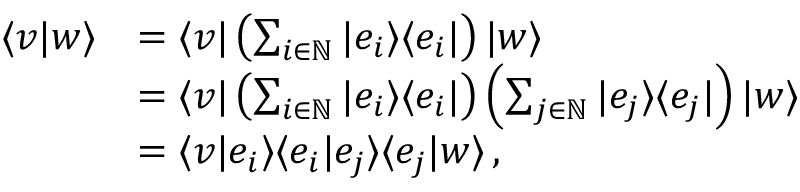Convert formula to latex. <formula><loc_0><loc_0><loc_500><loc_500>{ \begin{array} { r l } { \langle v | w \rangle } & { = \langle v | \left ( \sum _ { i \in \mathbb { N } } | e _ { i } \rangle \langle e _ { i } | \right ) | w \rangle } \\ & { = \langle v | \left ( \sum _ { i \in \mathbb { N } } | e _ { i } \rangle \langle e _ { i } | \right ) \left ( \sum _ { j \in \mathbb { N } } | e _ { j } \rangle \langle e _ { j } | \right ) | w \rangle } \\ & { = \langle v | e _ { i } \rangle \langle e _ { i } | e _ { j } \rangle \langle e _ { j } | w \rangle \, , } \end{array} }</formula> 